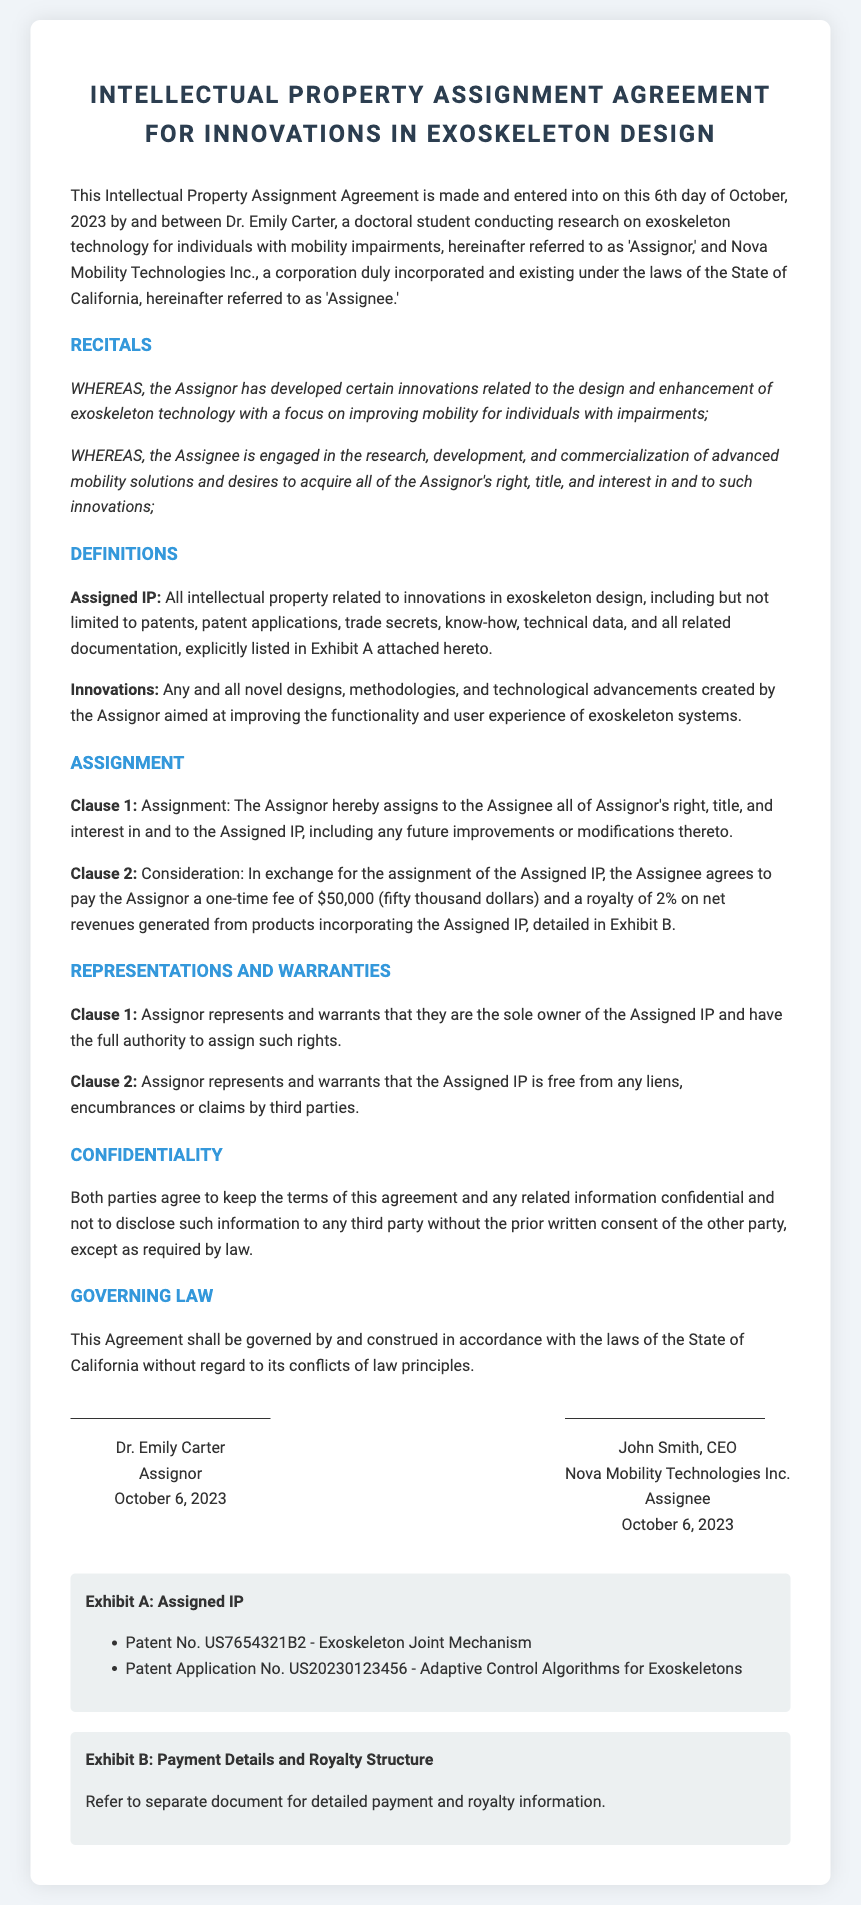What is the name of the Assignor? The Assignor is identified as Dr. Emily Carter in the document.
Answer: Dr. Emily Carter Who is the Assignee? The Assignee is Nova Mobility Technologies Inc., as stated in the document.
Answer: Nova Mobility Technologies Inc What is the assigned payment amount for the Assigned IP? The document specifies a one-time fee of $50,000 to be paid to the Assignor.
Answer: $50,000 On what date was the agreement made? The agreement is dated October 6, 2023, according to the document.
Answer: October 6, 2023 What percentage royalty is agreed upon on net revenues? A royalty of 2% on net revenues is mentioned in the agreement.
Answer: 2% What does "Assigned IP" refer to? "Assigned IP" refers to all intellectual property related to innovations in exoskeleton design as defined in the document.
Answer: All intellectual property related to innovations in exoskeleton design What is the governing law for the agreement? The agreement states that it shall be governed by the laws of the State of California.
Answer: State of California What representations does the Assignor make regarding ownership? The Assignor represents that they are the sole owner of the Assigned IP as stated in the representations section.
Answer: Sole owner What does Exhibit A list? Exhibit A lists the assigned intellectual properties, specifically patents and patent applications related to exoskeleton technology.
Answer: Patent No. US7654321B2 and Patent Application No. US20230123456 